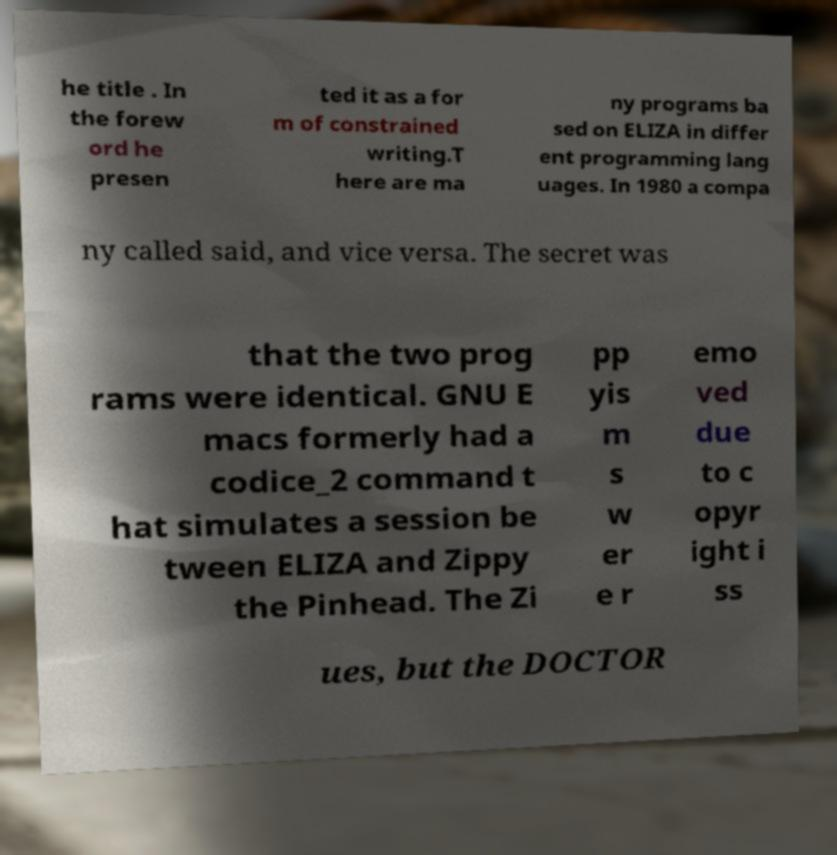I need the written content from this picture converted into text. Can you do that? he title . In the forew ord he presen ted it as a for m of constrained writing.T here are ma ny programs ba sed on ELIZA in differ ent programming lang uages. In 1980 a compa ny called said, and vice versa. The secret was that the two prog rams were identical. GNU E macs formerly had a codice_2 command t hat simulates a session be tween ELIZA and Zippy the Pinhead. The Zi pp yis m s w er e r emo ved due to c opyr ight i ss ues, but the DOCTOR 